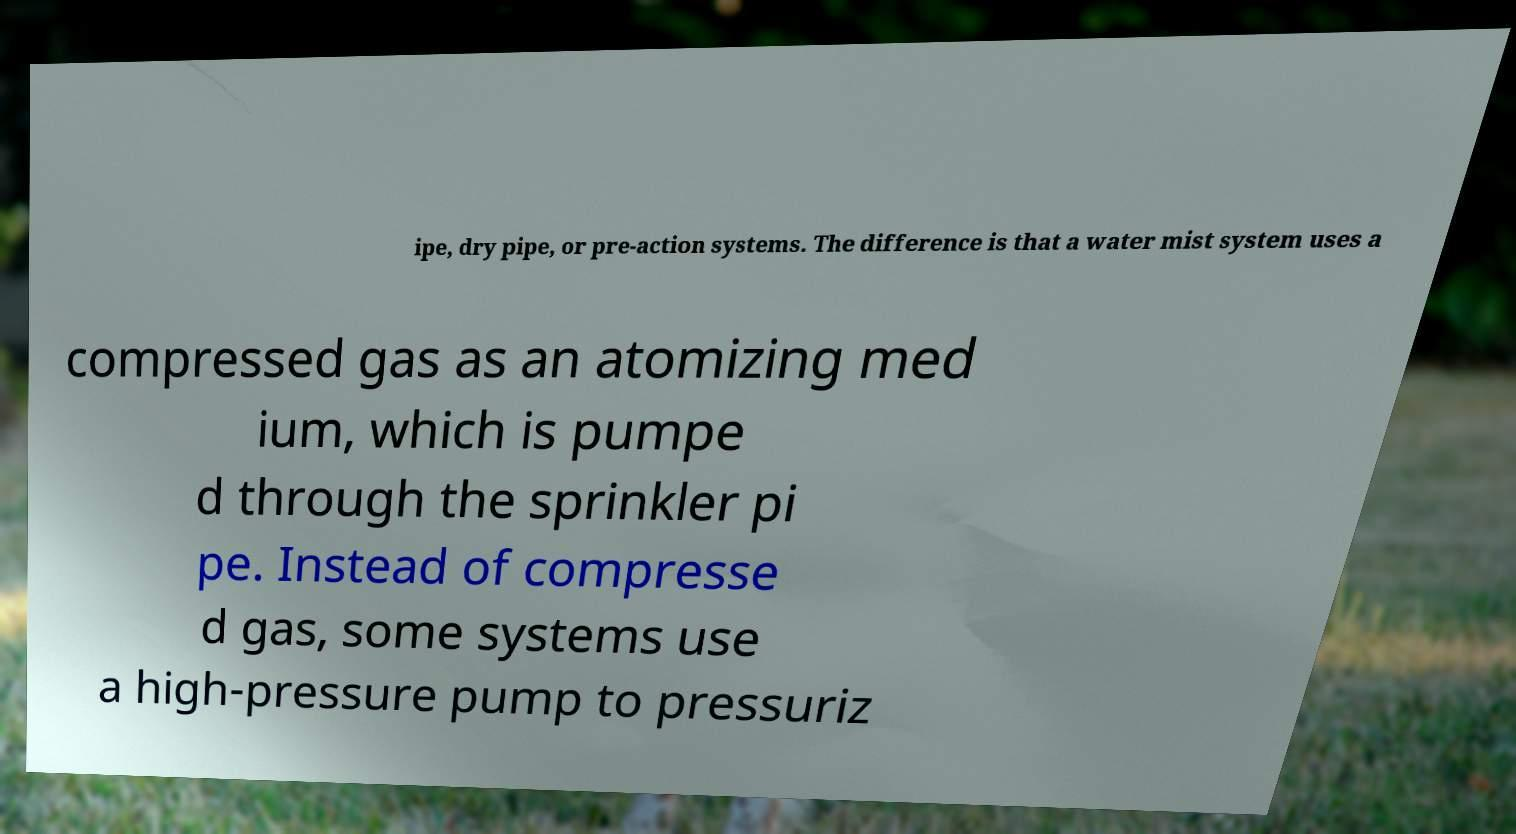Please identify and transcribe the text found in this image. ipe, dry pipe, or pre-action systems. The difference is that a water mist system uses a compressed gas as an atomizing med ium, which is pumpe d through the sprinkler pi pe. Instead of compresse d gas, some systems use a high-pressure pump to pressuriz 